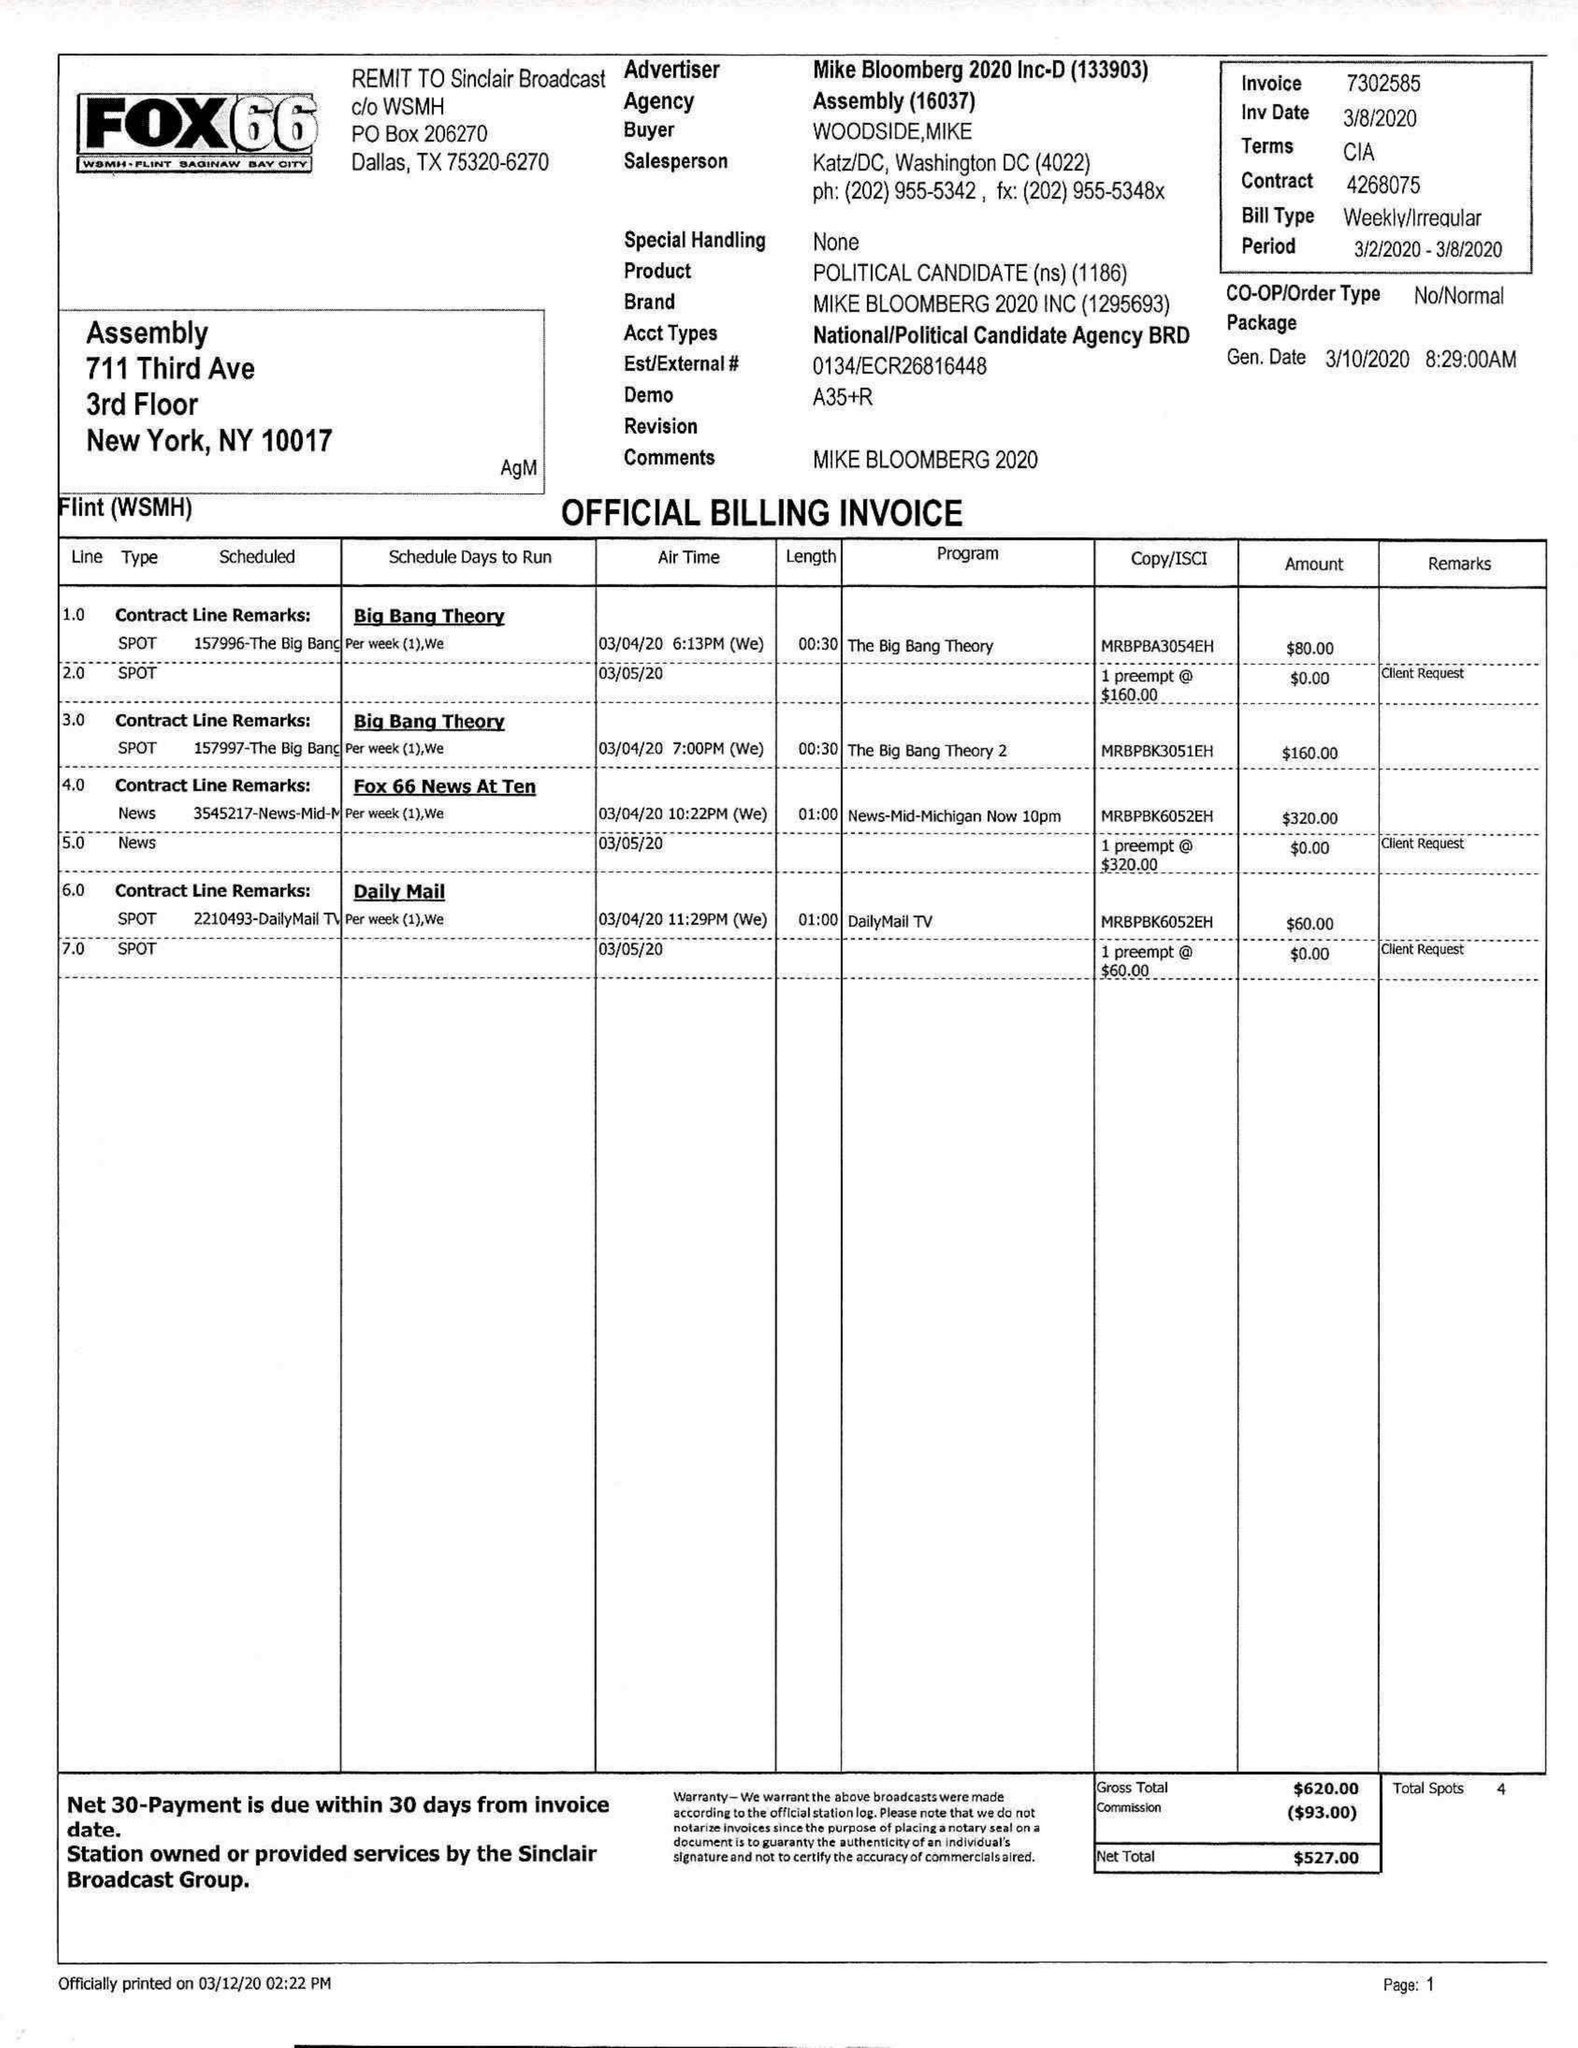What is the value for the flight_from?
Answer the question using a single word or phrase. 03/02/20 